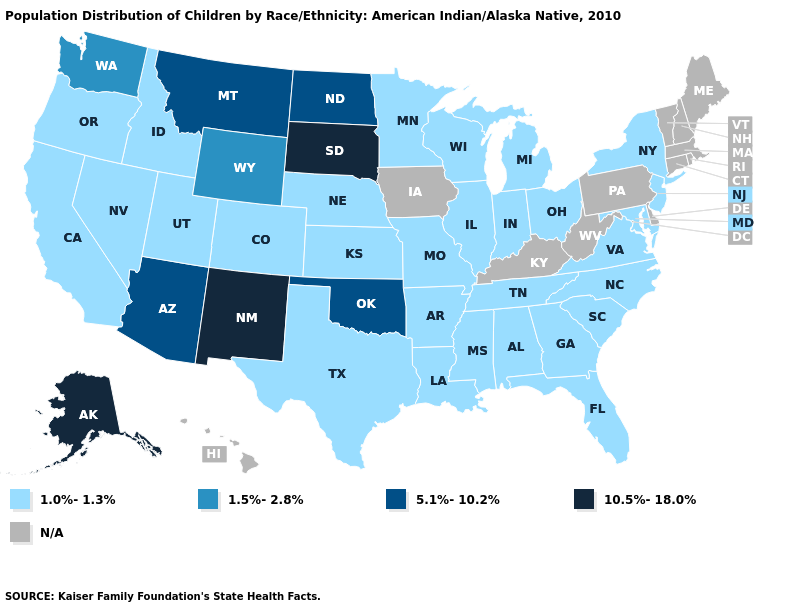Name the states that have a value in the range 10.5%-18.0%?
Be succinct. Alaska, New Mexico, South Dakota. Does Oklahoma have the highest value in the South?
Give a very brief answer. Yes. What is the highest value in the USA?
Write a very short answer. 10.5%-18.0%. Name the states that have a value in the range 5.1%-10.2%?
Quick response, please. Arizona, Montana, North Dakota, Oklahoma. What is the highest value in states that border Connecticut?
Answer briefly. 1.0%-1.3%. Name the states that have a value in the range 10.5%-18.0%?
Give a very brief answer. Alaska, New Mexico, South Dakota. Among the states that border Montana , does South Dakota have the highest value?
Short answer required. Yes. Among the states that border North Dakota , which have the lowest value?
Write a very short answer. Minnesota. What is the value of West Virginia?
Answer briefly. N/A. What is the value of Minnesota?
Write a very short answer. 1.0%-1.3%. Does the map have missing data?
Quick response, please. Yes. What is the value of Alabama?
Short answer required. 1.0%-1.3%. Which states have the highest value in the USA?
Write a very short answer. Alaska, New Mexico, South Dakota. 